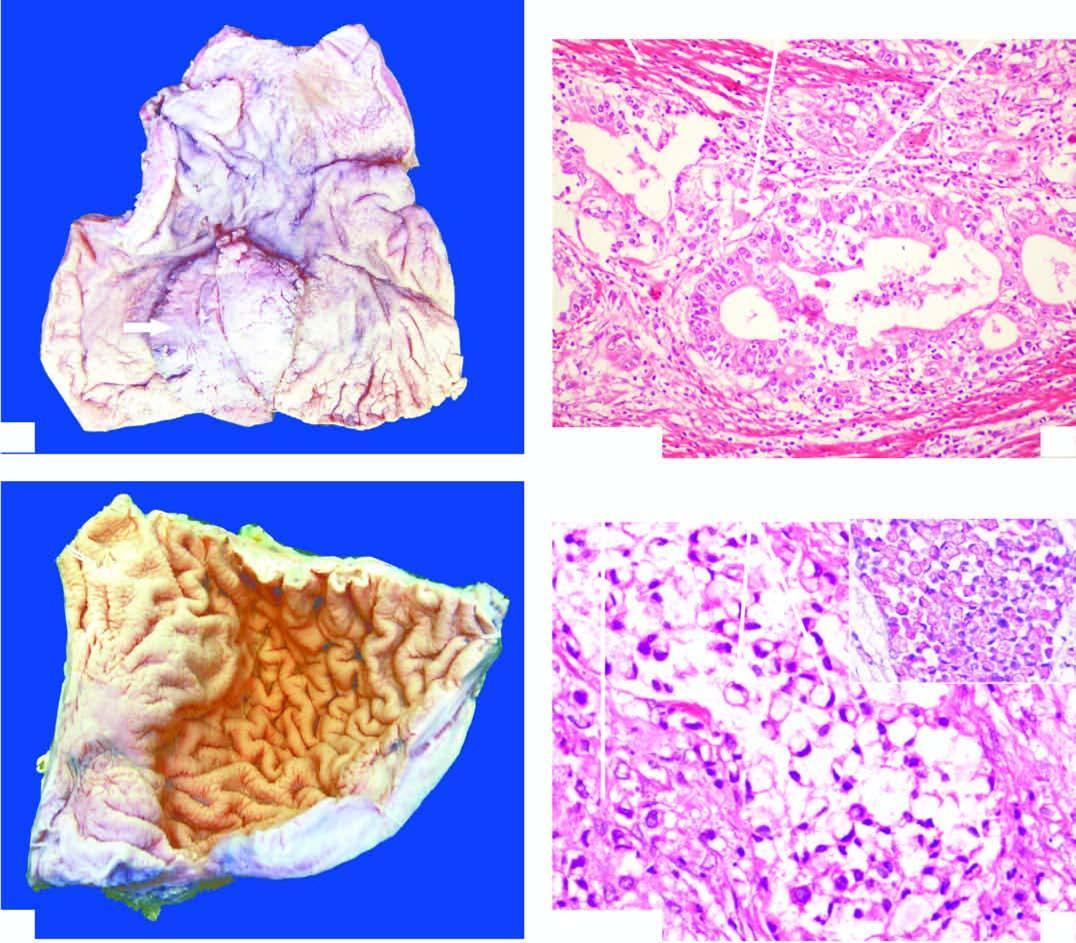what is desmoplastic?
Answer the question using a single word or phrase. Stroma 